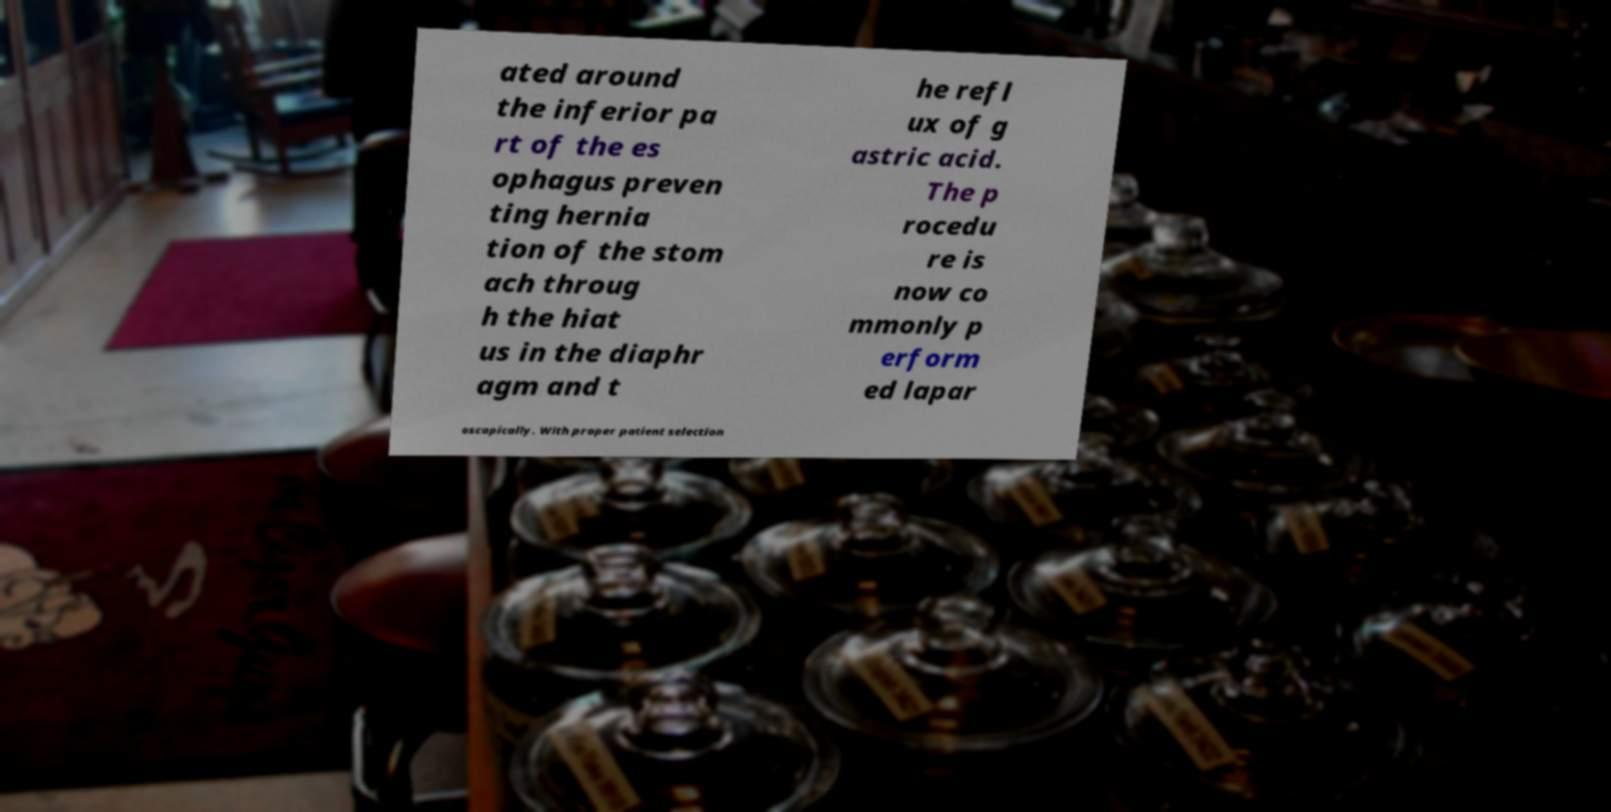For documentation purposes, I need the text within this image transcribed. Could you provide that? ated around the inferior pa rt of the es ophagus preven ting hernia tion of the stom ach throug h the hiat us in the diaphr agm and t he refl ux of g astric acid. The p rocedu re is now co mmonly p erform ed lapar oscopically. With proper patient selection 